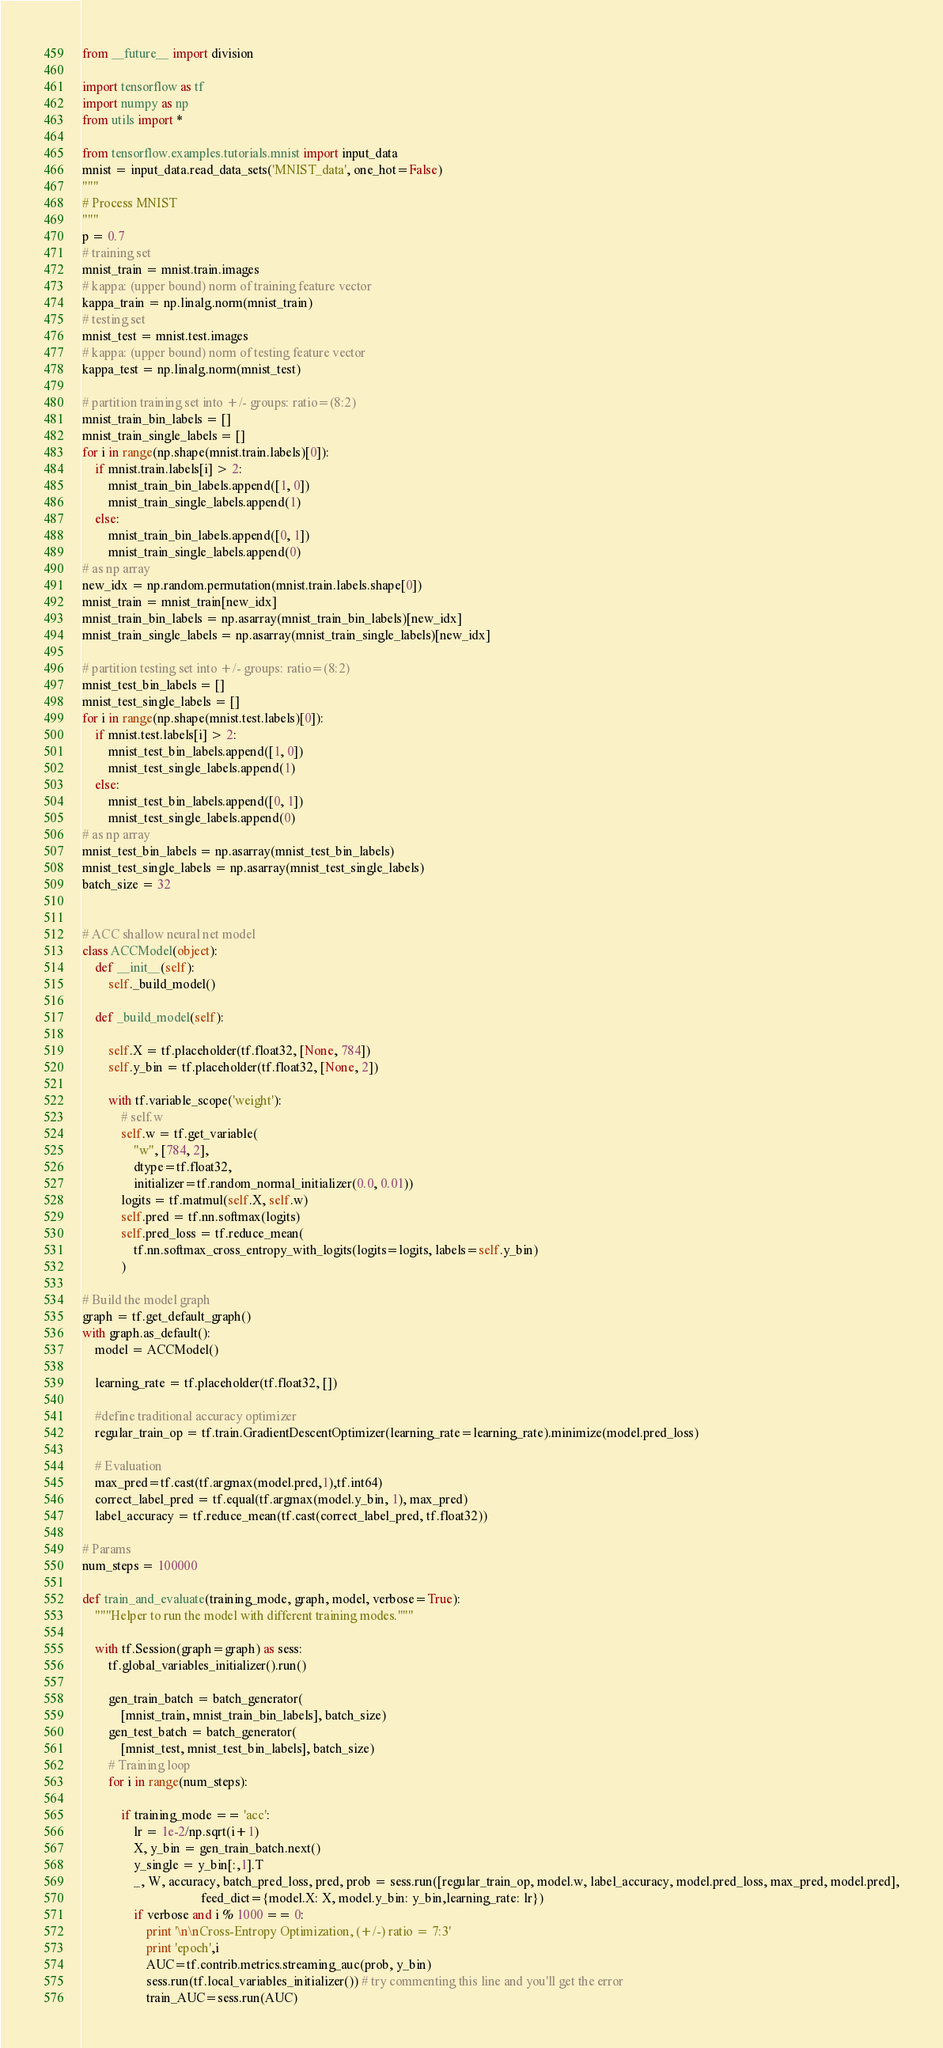Convert code to text. <code><loc_0><loc_0><loc_500><loc_500><_Python_>from __future__ import division

import tensorflow as tf
import numpy as np
from utils import *

from tensorflow.examples.tutorials.mnist import input_data
mnist = input_data.read_data_sets('MNIST_data', one_hot=False)
"""
# Process MNIST
"""
p = 0.7
# training set
mnist_train = mnist.train.images
# kappa: (upper bound) norm of training feature vector
kappa_train = np.linalg.norm(mnist_train)
# testing set
mnist_test = mnist.test.images
# kappa: (upper bound) norm of testing feature vector
kappa_test = np.linalg.norm(mnist_test)

# partition training set into +/- groups: ratio=(8:2)
mnist_train_bin_labels = []
mnist_train_single_labels = []
for i in range(np.shape(mnist.train.labels)[0]):
    if mnist.train.labels[i] > 2:
        mnist_train_bin_labels.append([1, 0])
        mnist_train_single_labels.append(1)
    else:
        mnist_train_bin_labels.append([0, 1])
        mnist_train_single_labels.append(0)
# as np array
new_idx = np.random.permutation(mnist.train.labels.shape[0])
mnist_train = mnist_train[new_idx]
mnist_train_bin_labels = np.asarray(mnist_train_bin_labels)[new_idx]
mnist_train_single_labels = np.asarray(mnist_train_single_labels)[new_idx]

# partition testing set into +/- groups: ratio=(8:2)
mnist_test_bin_labels = []
mnist_test_single_labels = []
for i in range(np.shape(mnist.test.labels)[0]):
    if mnist.test.labels[i] > 2:
        mnist_test_bin_labels.append([1, 0])
        mnist_test_single_labels.append(1)
    else:
        mnist_test_bin_labels.append([0, 1])
        mnist_test_single_labels.append(0)
# as np array
mnist_test_bin_labels = np.asarray(mnist_test_bin_labels)
mnist_test_single_labels = np.asarray(mnist_test_single_labels)
batch_size = 32


# ACC shallow neural net model
class ACCModel(object):
    def __init__(self):
        self._build_model()

    def _build_model(self):

        self.X = tf.placeholder(tf.float32, [None, 784])
        self.y_bin = tf.placeholder(tf.float32, [None, 2])

        with tf.variable_scope('weight'):
            # self.w
            self.w = tf.get_variable(
                "w", [784, 2],
                dtype=tf.float32,
                initializer=tf.random_normal_initializer(0.0, 0.01))
            logits = tf.matmul(self.X, self.w)
            self.pred = tf.nn.softmax(logits)
            self.pred_loss = tf.reduce_mean(
                tf.nn.softmax_cross_entropy_with_logits(logits=logits, labels=self.y_bin)
            )

# Build the model graph
graph = tf.get_default_graph()
with graph.as_default():
    model = ACCModel()

    learning_rate = tf.placeholder(tf.float32, [])

    #define traditional accuracy optimizer
    regular_train_op = tf.train.GradientDescentOptimizer(learning_rate=learning_rate).minimize(model.pred_loss)

    # Evaluation
    max_pred=tf.cast(tf.argmax(model.pred,1),tf.int64)
    correct_label_pred = tf.equal(tf.argmax(model.y_bin, 1), max_pred)
    label_accuracy = tf.reduce_mean(tf.cast(correct_label_pred, tf.float32))

# Params
num_steps = 100000

def train_and_evaluate(training_mode, graph, model, verbose=True):
    """Helper to run the model with different training modes."""

    with tf.Session(graph=graph) as sess:
        tf.global_variables_initializer().run()

        gen_train_batch = batch_generator(
            [mnist_train, mnist_train_bin_labels], batch_size)
        gen_test_batch = batch_generator(
            [mnist_test, mnist_test_bin_labels], batch_size)
        # Training loop
        for i in range(num_steps):

            if training_mode == 'acc':
                lr = 1e-2/np.sqrt(i+1)
                X, y_bin = gen_train_batch.next()
                y_single = y_bin[:,1].T
                _, W, accuracy, batch_pred_loss, pred, prob = sess.run([regular_train_op, model.w, label_accuracy, model.pred_loss, max_pred, model.pred],
                                     feed_dict={model.X: X, model.y_bin: y_bin,learning_rate: lr})
                if verbose and i % 1000 == 0:
                    print '\n\nCross-Entropy Optimization, (+/-) ratio = 7:3'
                    print 'epoch',i
                    AUC=tf.contrib.metrics.streaming_auc(prob, y_bin)
                    sess.run(tf.local_variables_initializer()) # try commenting this line and you'll get the error
                    train_AUC=sess.run(AUC)</code> 